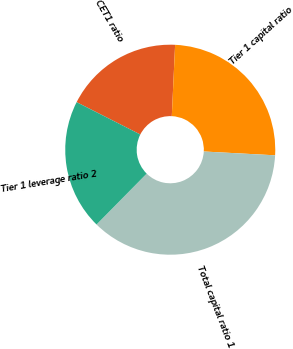Convert chart. <chart><loc_0><loc_0><loc_500><loc_500><pie_chart><fcel>CET1 ratio<fcel>Tier 1 capital ratio<fcel>Total capital ratio 1<fcel>Tier 1 leverage ratio 2<nl><fcel>18.26%<fcel>25.11%<fcel>36.53%<fcel>20.09%<nl></chart> 